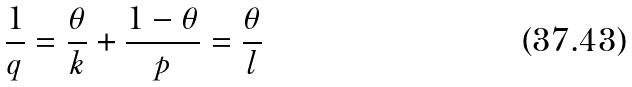<formula> <loc_0><loc_0><loc_500><loc_500>\frac { 1 } { q } = \frac { \theta } { k } + \frac { 1 - \theta } { p } = \frac { \theta } { l }</formula> 